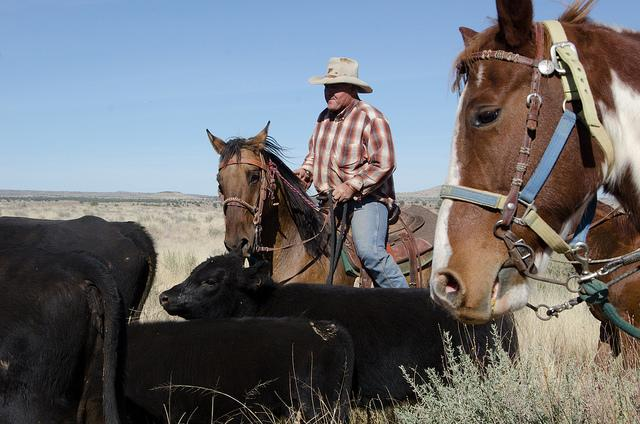How did this man get to this location? Please explain your reasoning. via horseback. Men are riding on horses. 